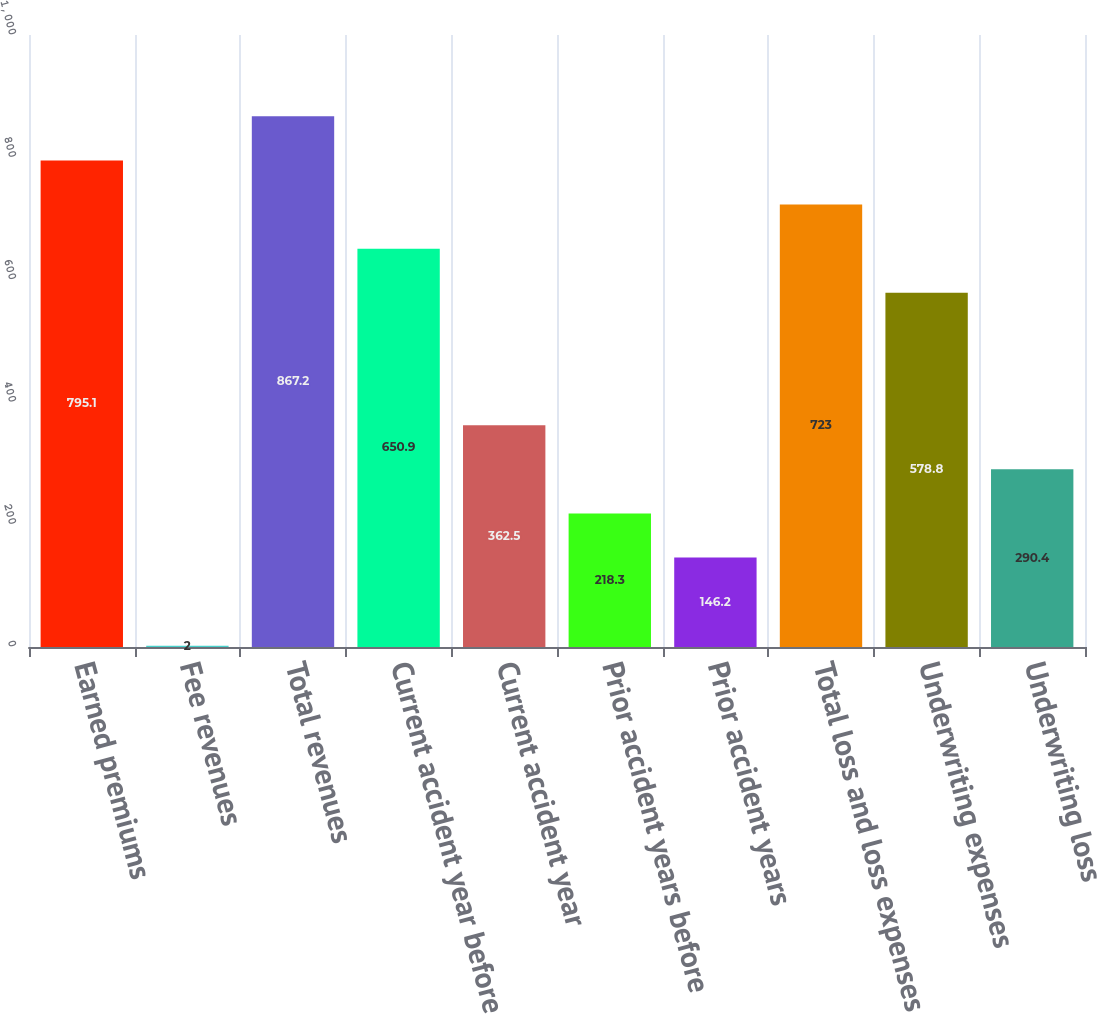<chart> <loc_0><loc_0><loc_500><loc_500><bar_chart><fcel>Earned premiums<fcel>Fee revenues<fcel>Total revenues<fcel>Current accident year before<fcel>Current accident year<fcel>Prior accident years before<fcel>Prior accident years<fcel>Total loss and loss expenses<fcel>Underwriting expenses<fcel>Underwriting loss<nl><fcel>795.1<fcel>2<fcel>867.2<fcel>650.9<fcel>362.5<fcel>218.3<fcel>146.2<fcel>723<fcel>578.8<fcel>290.4<nl></chart> 